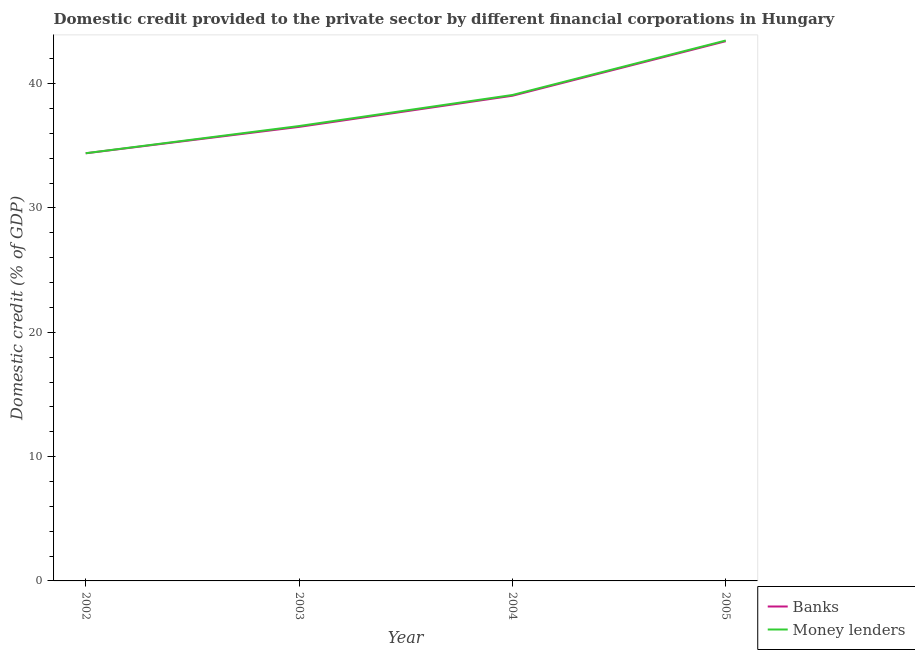How many different coloured lines are there?
Your answer should be compact. 2. Does the line corresponding to domestic credit provided by banks intersect with the line corresponding to domestic credit provided by money lenders?
Your answer should be very brief. No. Is the number of lines equal to the number of legend labels?
Offer a terse response. Yes. What is the domestic credit provided by banks in 2005?
Your response must be concise. 43.42. Across all years, what is the maximum domestic credit provided by money lenders?
Offer a terse response. 43.47. Across all years, what is the minimum domestic credit provided by money lenders?
Make the answer very short. 34.41. In which year was the domestic credit provided by banks maximum?
Give a very brief answer. 2005. In which year was the domestic credit provided by banks minimum?
Keep it short and to the point. 2002. What is the total domestic credit provided by banks in the graph?
Give a very brief answer. 153.37. What is the difference between the domestic credit provided by money lenders in 2003 and that in 2005?
Make the answer very short. -6.88. What is the difference between the domestic credit provided by money lenders in 2004 and the domestic credit provided by banks in 2003?
Keep it short and to the point. 2.57. What is the average domestic credit provided by money lenders per year?
Make the answer very short. 38.39. In the year 2004, what is the difference between the domestic credit provided by money lenders and domestic credit provided by banks?
Your answer should be very brief. 0.06. In how many years, is the domestic credit provided by money lenders greater than 10 %?
Your answer should be very brief. 4. What is the ratio of the domestic credit provided by banks in 2002 to that in 2003?
Provide a succinct answer. 0.94. Is the domestic credit provided by banks in 2003 less than that in 2005?
Your response must be concise. Yes. Is the difference between the domestic credit provided by banks in 2004 and 2005 greater than the difference between the domestic credit provided by money lenders in 2004 and 2005?
Provide a succinct answer. No. What is the difference between the highest and the second highest domestic credit provided by money lenders?
Make the answer very short. 4.38. What is the difference between the highest and the lowest domestic credit provided by banks?
Provide a succinct answer. 9.02. In how many years, is the domestic credit provided by money lenders greater than the average domestic credit provided by money lenders taken over all years?
Give a very brief answer. 2. Does the domestic credit provided by banks monotonically increase over the years?
Make the answer very short. Yes. Is the domestic credit provided by money lenders strictly greater than the domestic credit provided by banks over the years?
Your answer should be compact. Yes. Is the domestic credit provided by money lenders strictly less than the domestic credit provided by banks over the years?
Keep it short and to the point. No. How many years are there in the graph?
Provide a succinct answer. 4. Are the values on the major ticks of Y-axis written in scientific E-notation?
Give a very brief answer. No. Does the graph contain any zero values?
Give a very brief answer. No. Does the graph contain grids?
Provide a short and direct response. No. Where does the legend appear in the graph?
Offer a very short reply. Bottom right. How many legend labels are there?
Offer a terse response. 2. How are the legend labels stacked?
Make the answer very short. Vertical. What is the title of the graph?
Make the answer very short. Domestic credit provided to the private sector by different financial corporations in Hungary. What is the label or title of the X-axis?
Your answer should be very brief. Year. What is the label or title of the Y-axis?
Your answer should be very brief. Domestic credit (% of GDP). What is the Domestic credit (% of GDP) in Banks in 2002?
Keep it short and to the point. 34.4. What is the Domestic credit (% of GDP) in Money lenders in 2002?
Ensure brevity in your answer.  34.41. What is the Domestic credit (% of GDP) of Banks in 2003?
Ensure brevity in your answer.  36.52. What is the Domestic credit (% of GDP) in Money lenders in 2003?
Your response must be concise. 36.59. What is the Domestic credit (% of GDP) in Banks in 2004?
Offer a terse response. 39.03. What is the Domestic credit (% of GDP) of Money lenders in 2004?
Make the answer very short. 39.09. What is the Domestic credit (% of GDP) in Banks in 2005?
Keep it short and to the point. 43.42. What is the Domestic credit (% of GDP) in Money lenders in 2005?
Provide a short and direct response. 43.47. Across all years, what is the maximum Domestic credit (% of GDP) of Banks?
Provide a short and direct response. 43.42. Across all years, what is the maximum Domestic credit (% of GDP) in Money lenders?
Make the answer very short. 43.47. Across all years, what is the minimum Domestic credit (% of GDP) of Banks?
Your response must be concise. 34.4. Across all years, what is the minimum Domestic credit (% of GDP) of Money lenders?
Provide a succinct answer. 34.41. What is the total Domestic credit (% of GDP) in Banks in the graph?
Your response must be concise. 153.37. What is the total Domestic credit (% of GDP) in Money lenders in the graph?
Your answer should be compact. 153.56. What is the difference between the Domestic credit (% of GDP) in Banks in 2002 and that in 2003?
Your answer should be very brief. -2.12. What is the difference between the Domestic credit (% of GDP) in Money lenders in 2002 and that in 2003?
Ensure brevity in your answer.  -2.19. What is the difference between the Domestic credit (% of GDP) of Banks in 2002 and that in 2004?
Offer a very short reply. -4.63. What is the difference between the Domestic credit (% of GDP) of Money lenders in 2002 and that in 2004?
Give a very brief answer. -4.68. What is the difference between the Domestic credit (% of GDP) of Banks in 2002 and that in 2005?
Keep it short and to the point. -9.02. What is the difference between the Domestic credit (% of GDP) of Money lenders in 2002 and that in 2005?
Make the answer very short. -9.07. What is the difference between the Domestic credit (% of GDP) of Banks in 2003 and that in 2004?
Offer a terse response. -2.5. What is the difference between the Domestic credit (% of GDP) of Money lenders in 2003 and that in 2004?
Your answer should be compact. -2.5. What is the difference between the Domestic credit (% of GDP) of Banks in 2003 and that in 2005?
Keep it short and to the point. -6.89. What is the difference between the Domestic credit (% of GDP) of Money lenders in 2003 and that in 2005?
Offer a terse response. -6.88. What is the difference between the Domestic credit (% of GDP) in Banks in 2004 and that in 2005?
Keep it short and to the point. -4.39. What is the difference between the Domestic credit (% of GDP) in Money lenders in 2004 and that in 2005?
Your response must be concise. -4.38. What is the difference between the Domestic credit (% of GDP) in Banks in 2002 and the Domestic credit (% of GDP) in Money lenders in 2003?
Offer a very short reply. -2.19. What is the difference between the Domestic credit (% of GDP) in Banks in 2002 and the Domestic credit (% of GDP) in Money lenders in 2004?
Give a very brief answer. -4.69. What is the difference between the Domestic credit (% of GDP) in Banks in 2002 and the Domestic credit (% of GDP) in Money lenders in 2005?
Offer a very short reply. -9.07. What is the difference between the Domestic credit (% of GDP) of Banks in 2003 and the Domestic credit (% of GDP) of Money lenders in 2004?
Provide a succinct answer. -2.57. What is the difference between the Domestic credit (% of GDP) in Banks in 2003 and the Domestic credit (% of GDP) in Money lenders in 2005?
Provide a short and direct response. -6.95. What is the difference between the Domestic credit (% of GDP) of Banks in 2004 and the Domestic credit (% of GDP) of Money lenders in 2005?
Your answer should be compact. -4.44. What is the average Domestic credit (% of GDP) of Banks per year?
Your response must be concise. 38.34. What is the average Domestic credit (% of GDP) of Money lenders per year?
Your answer should be compact. 38.39. In the year 2002, what is the difference between the Domestic credit (% of GDP) of Banks and Domestic credit (% of GDP) of Money lenders?
Your answer should be very brief. -0. In the year 2003, what is the difference between the Domestic credit (% of GDP) in Banks and Domestic credit (% of GDP) in Money lenders?
Offer a terse response. -0.07. In the year 2004, what is the difference between the Domestic credit (% of GDP) in Banks and Domestic credit (% of GDP) in Money lenders?
Your answer should be compact. -0.06. In the year 2005, what is the difference between the Domestic credit (% of GDP) in Banks and Domestic credit (% of GDP) in Money lenders?
Make the answer very short. -0.06. What is the ratio of the Domestic credit (% of GDP) of Banks in 2002 to that in 2003?
Your response must be concise. 0.94. What is the ratio of the Domestic credit (% of GDP) of Money lenders in 2002 to that in 2003?
Offer a very short reply. 0.94. What is the ratio of the Domestic credit (% of GDP) of Banks in 2002 to that in 2004?
Provide a short and direct response. 0.88. What is the ratio of the Domestic credit (% of GDP) in Money lenders in 2002 to that in 2004?
Ensure brevity in your answer.  0.88. What is the ratio of the Domestic credit (% of GDP) in Banks in 2002 to that in 2005?
Offer a very short reply. 0.79. What is the ratio of the Domestic credit (% of GDP) of Money lenders in 2002 to that in 2005?
Provide a short and direct response. 0.79. What is the ratio of the Domestic credit (% of GDP) in Banks in 2003 to that in 2004?
Offer a very short reply. 0.94. What is the ratio of the Domestic credit (% of GDP) in Money lenders in 2003 to that in 2004?
Your answer should be very brief. 0.94. What is the ratio of the Domestic credit (% of GDP) of Banks in 2003 to that in 2005?
Offer a very short reply. 0.84. What is the ratio of the Domestic credit (% of GDP) of Money lenders in 2003 to that in 2005?
Give a very brief answer. 0.84. What is the ratio of the Domestic credit (% of GDP) of Banks in 2004 to that in 2005?
Provide a succinct answer. 0.9. What is the ratio of the Domestic credit (% of GDP) in Money lenders in 2004 to that in 2005?
Offer a very short reply. 0.9. What is the difference between the highest and the second highest Domestic credit (% of GDP) in Banks?
Keep it short and to the point. 4.39. What is the difference between the highest and the second highest Domestic credit (% of GDP) of Money lenders?
Your response must be concise. 4.38. What is the difference between the highest and the lowest Domestic credit (% of GDP) of Banks?
Make the answer very short. 9.02. What is the difference between the highest and the lowest Domestic credit (% of GDP) in Money lenders?
Your response must be concise. 9.07. 